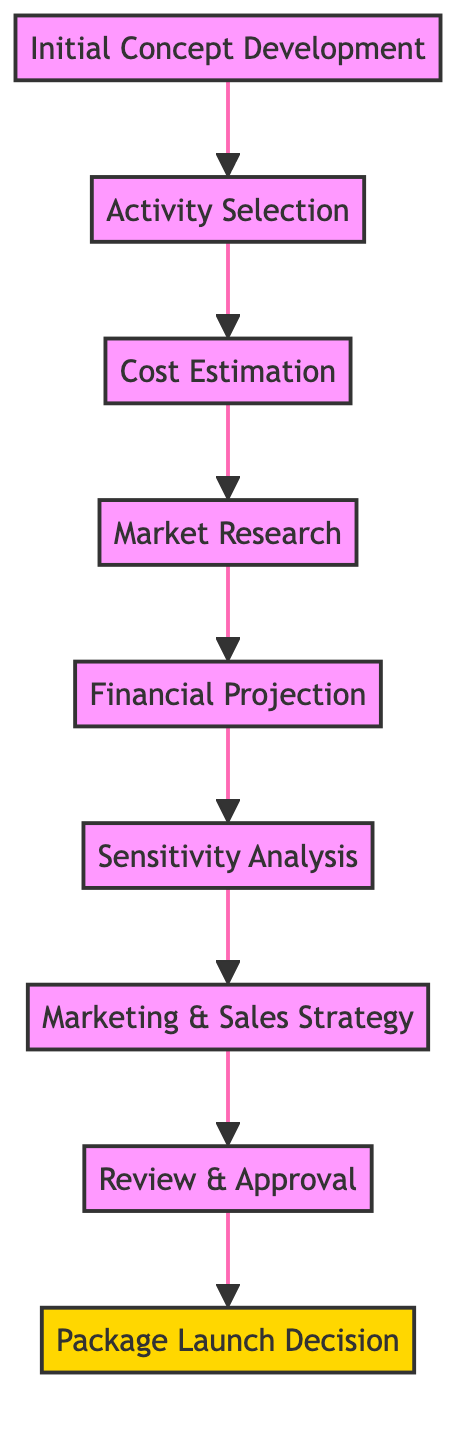What is the first step in the evaluation process? The diagram illustrates that the first step is "Initial Concept Development," which is the starting point of the flow.
Answer: Initial Concept Development How many total steps are there in the evaluation process? Counting from "Initial Concept Development" to "Package Launch Decision," there are 8 total steps in the flowchart.
Answer: 8 What follows "Financial Projection" in the evaluation process? The step that follows "Financial Projection" is "Sensitivity Analysis," indicating the next action to be taken after financial projections are made.
Answer: Sensitivity Analysis Which step involves determining the overall costs? The step dedicated to estimating costs is "Cost Estimation," which focuses on calculating the total costs associated with the vacation package.
Answer: Cost Estimation What is the final step before making the launch decision? The last step before the "Package Launch Decision" is "Review & Approval," which involves obtaining necessary approvals from management.
Answer: Review & Approval What type of analysis is done right after the financial projections? A "Sensitivity Analysis" is performed right after the financial projections to assess how different variables impact profitability.
Answer: Sensitivity Analysis Which step directly leads to developing marketing strategies? The "Marketing & Sales Strategy" step directly follows "Sensitivity Analysis," indicating that marketing strategies hinge on the results of that analysis.
Answer: Marketing & Sales Strategy What is indicated by the culmination of this process in the flowchart? The final node "Package Launch Decision" indicates the culmination of the entire evaluation process, showing the ultimate goal of the analysis.
Answer: Package Launch Decision 